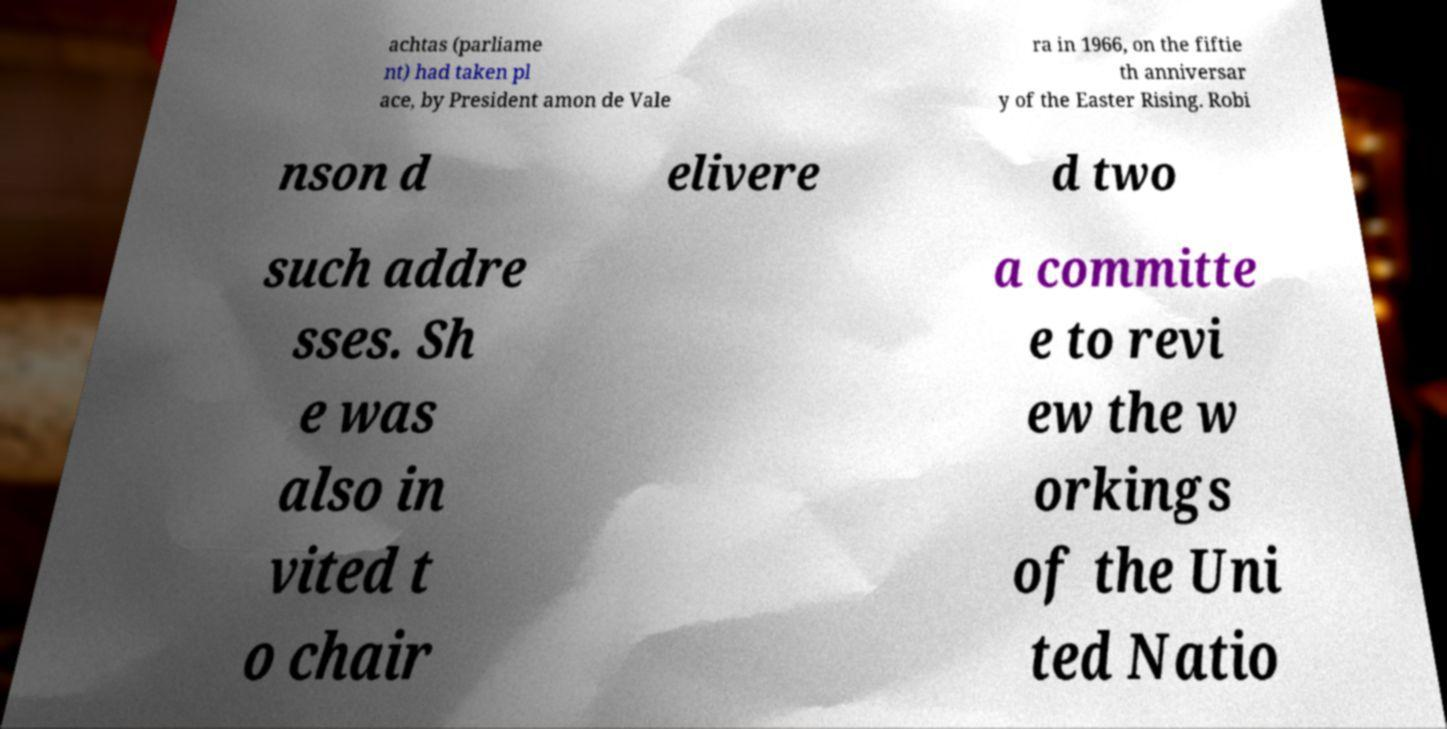For documentation purposes, I need the text within this image transcribed. Could you provide that? achtas (parliame nt) had taken pl ace, by President amon de Vale ra in 1966, on the fiftie th anniversar y of the Easter Rising. Robi nson d elivere d two such addre sses. Sh e was also in vited t o chair a committe e to revi ew the w orkings of the Uni ted Natio 